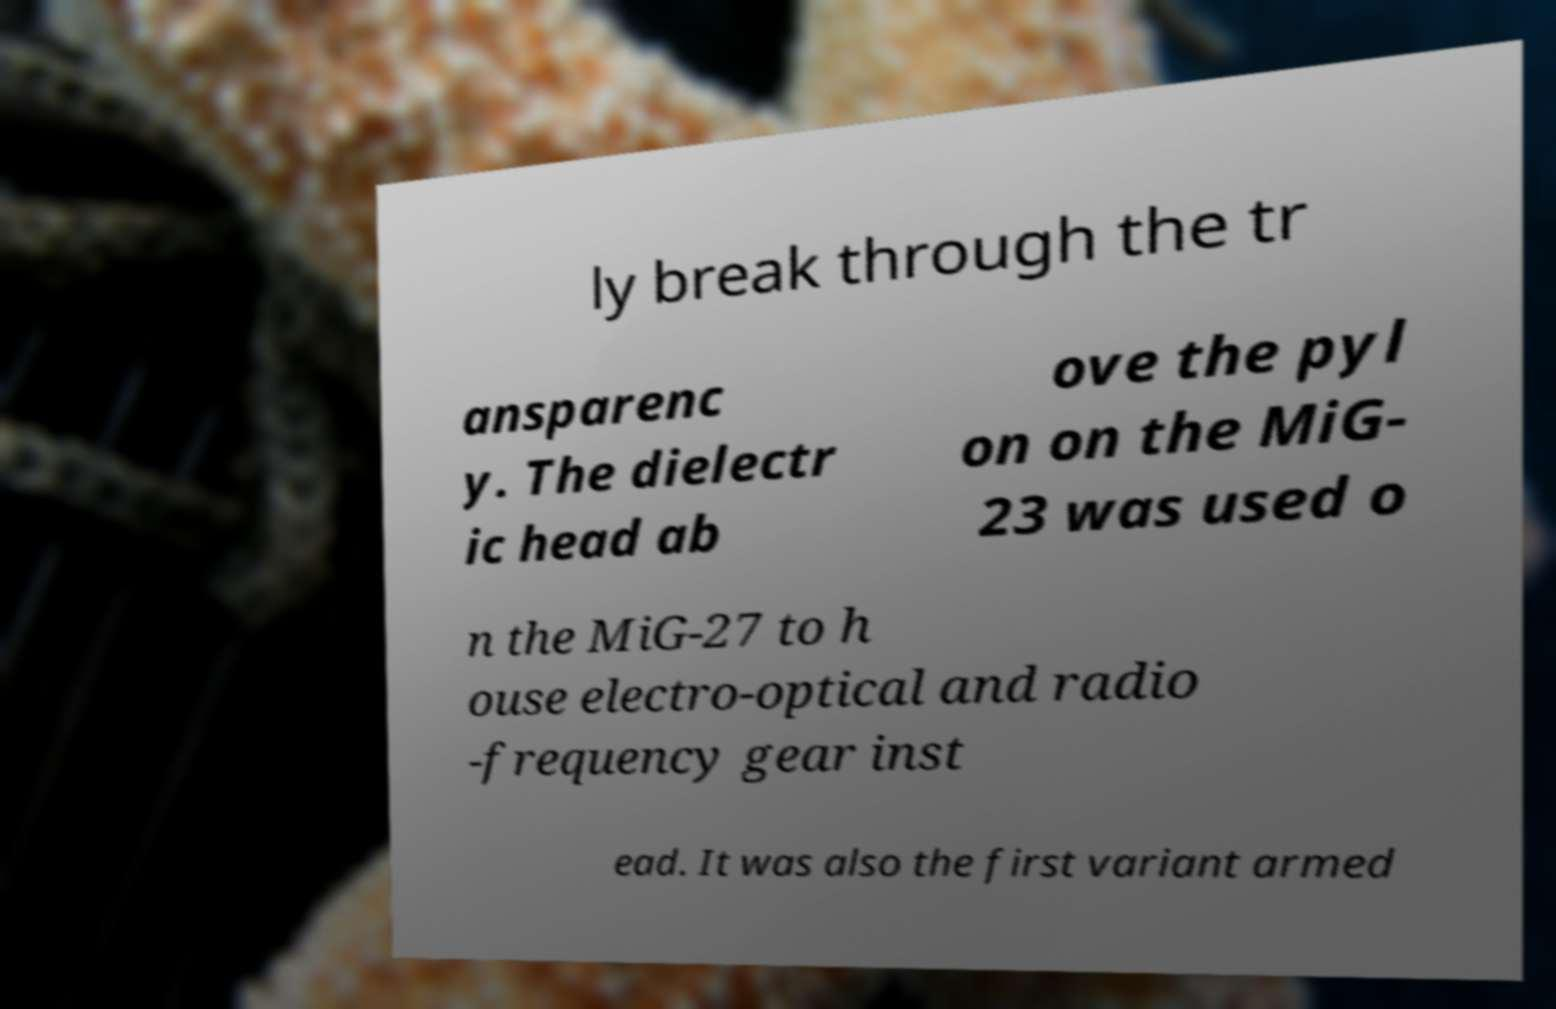Can you read and provide the text displayed in the image?This photo seems to have some interesting text. Can you extract and type it out for me? ly break through the tr ansparenc y. The dielectr ic head ab ove the pyl on on the MiG- 23 was used o n the MiG-27 to h ouse electro-optical and radio -frequency gear inst ead. It was also the first variant armed 